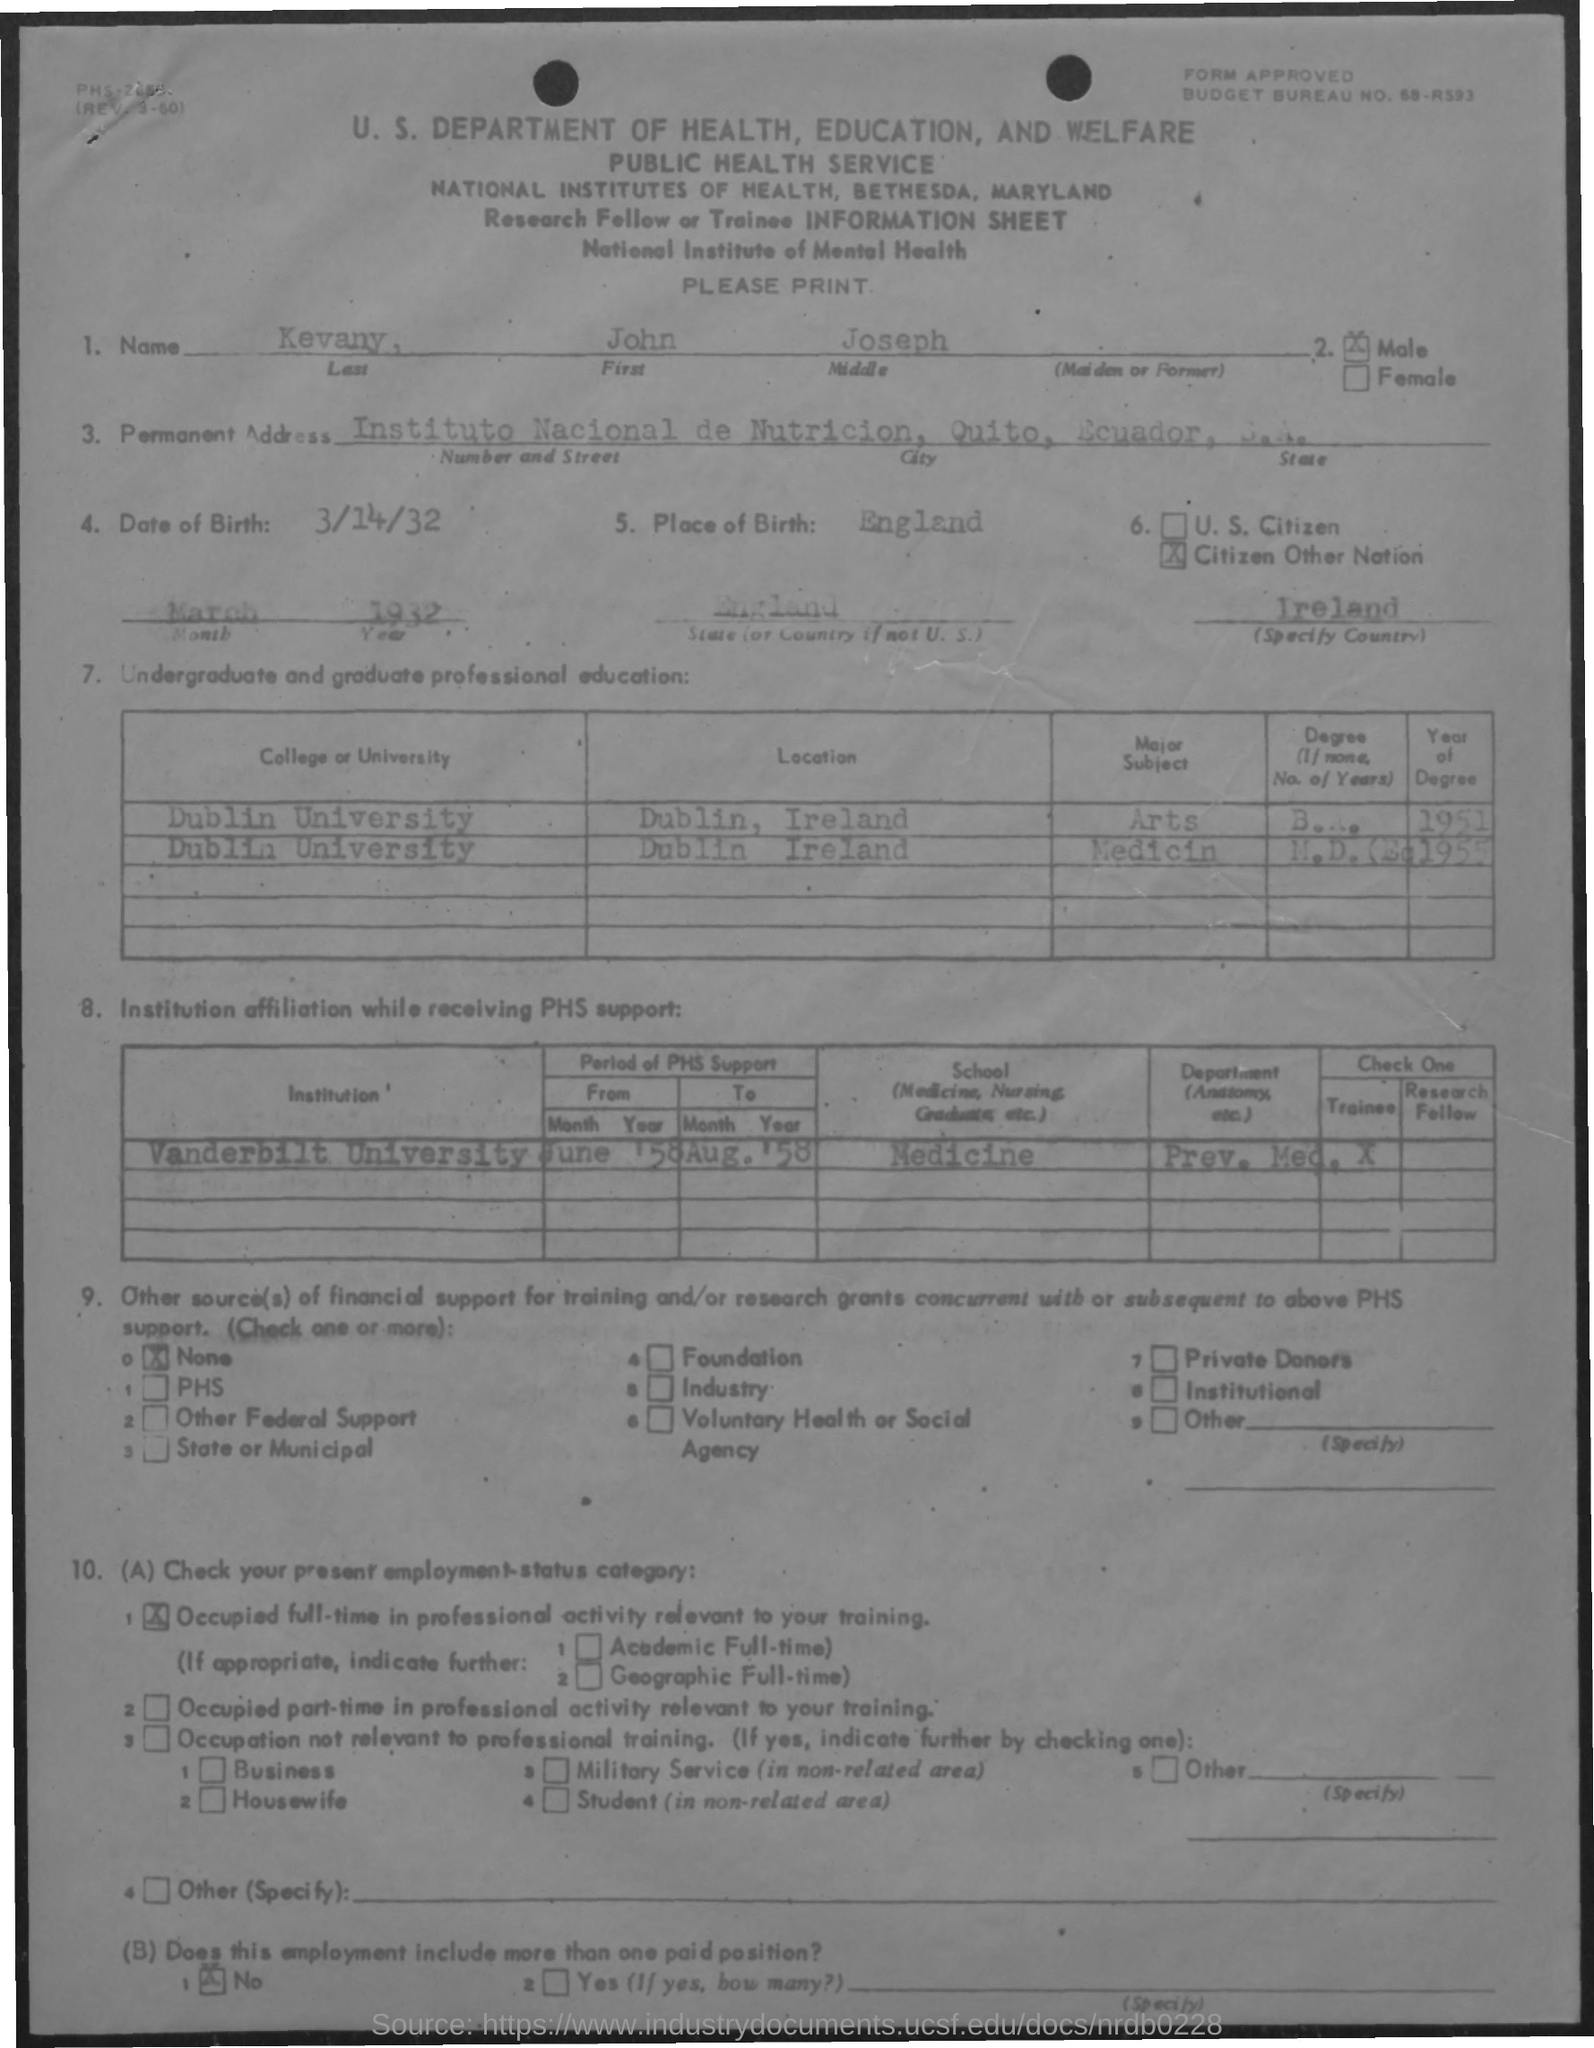Draw attention to some important aspects in this diagram. The date of birth is March 14, 1932. The first name mentioned in the document is John. The place of birth of the individual in question is England. 